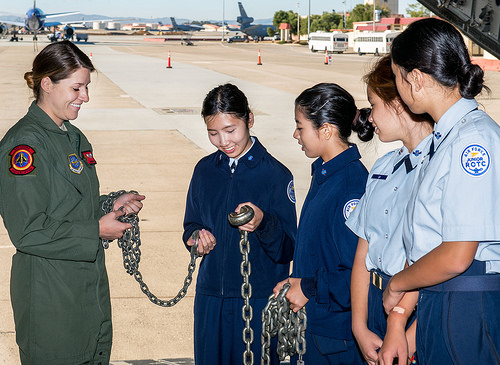<image>
Can you confirm if the woman is to the right of the girl? No. The woman is not to the right of the girl. The horizontal positioning shows a different relationship. 